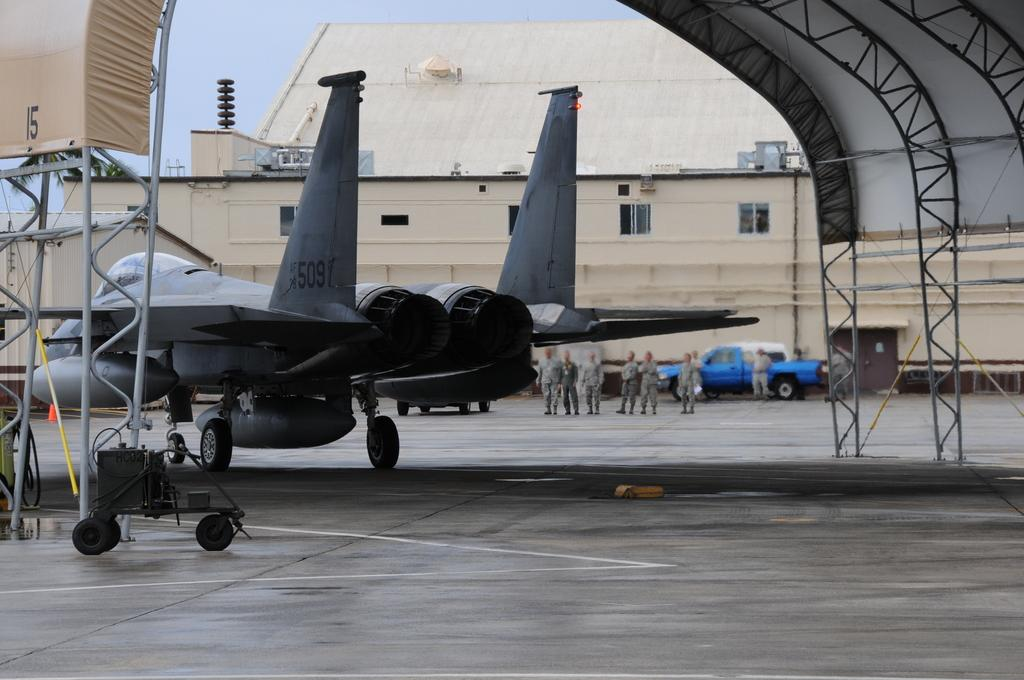<image>
Render a clear and concise summary of the photo. an Air Force plane with number 509 on the tail 